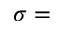Convert formula to latex. <formula><loc_0><loc_0><loc_500><loc_500>\sigma =</formula> 